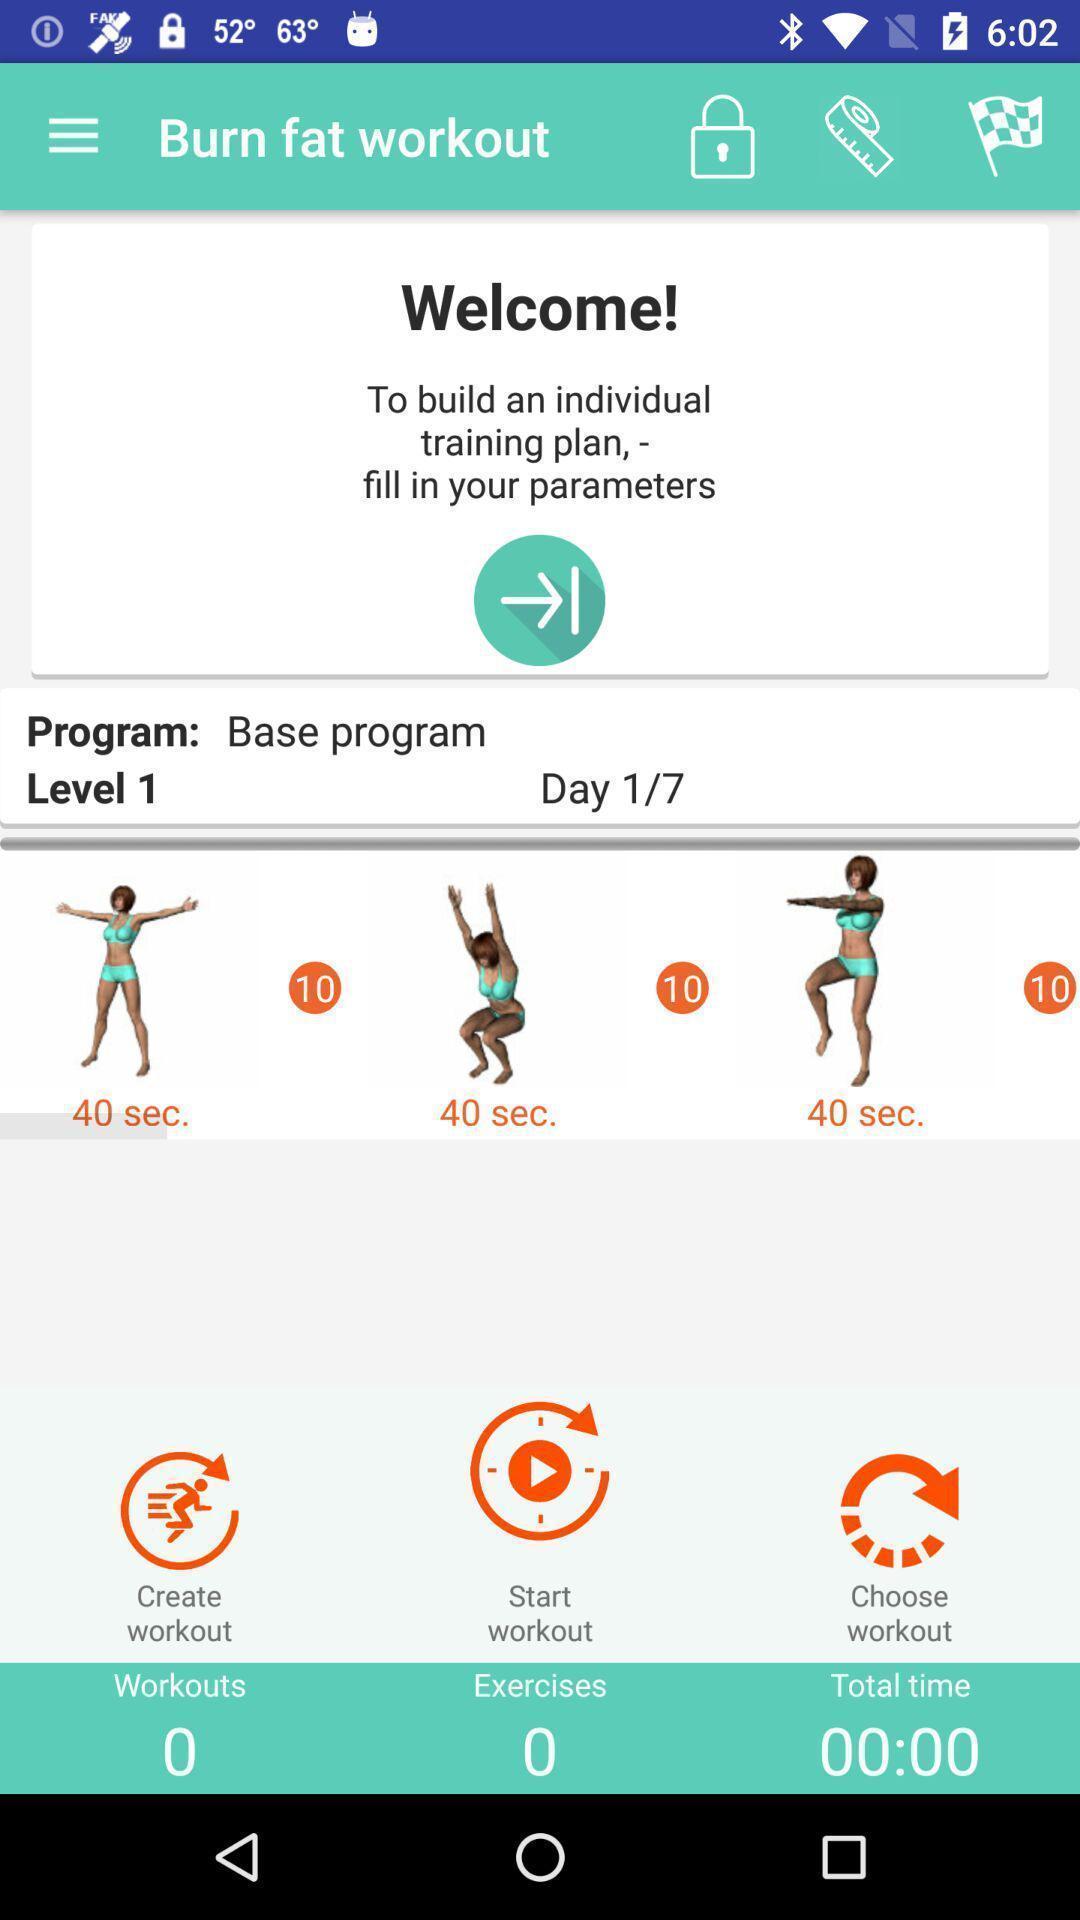Summarize the information in this screenshot. Welcome page of a fitness app. 